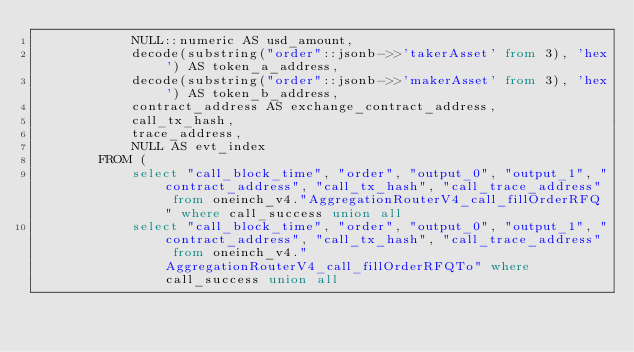Convert code to text. <code><loc_0><loc_0><loc_500><loc_500><_SQL_>            NULL::numeric AS usd_amount,
            decode(substring("order"::jsonb->>'takerAsset' from 3), 'hex') AS token_a_address,
            decode(substring("order"::jsonb->>'makerAsset' from 3), 'hex') AS token_b_address,
            contract_address AS exchange_contract_address,
            call_tx_hash,
            trace_address,
            NULL AS evt_index
        FROM (
            select "call_block_time", "order", "output_0", "output_1", "contract_address", "call_tx_hash", "call_trace_address" from oneinch_v4."AggregationRouterV4_call_fillOrderRFQ" where call_success union all
            select "call_block_time", "order", "output_0", "output_1", "contract_address", "call_tx_hash", "call_trace_address" from oneinch_v4."AggregationRouterV4_call_fillOrderRFQTo" where call_success union all</code> 